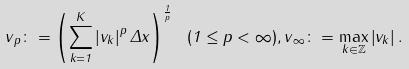<formula> <loc_0><loc_0><loc_500><loc_500>\| v \| _ { p } \colon = \left ( \sum _ { k = 1 } ^ { K } \left | v _ { k } \right | ^ { p } \Delta x \right ) ^ { \frac { 1 } { p } } \ ( 1 \leq p < \infty ) , \| v \| _ { \infty } \colon = \max _ { k \in \mathbb { Z } } \left | v _ { k } \right | .</formula> 